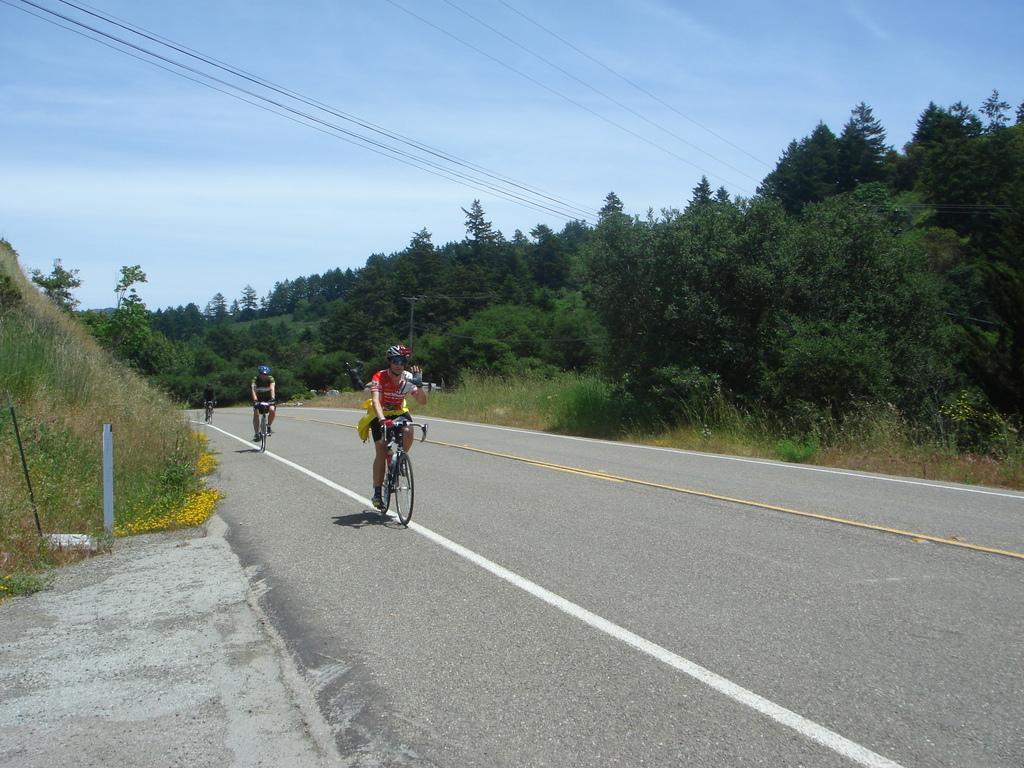Could you give a brief overview of what you see in this image? In this image, we can see people wearing helmets and are riding bicycles. In the background, there are trees, poles, wires and there is grass. At the top, there is sky and at the bottom, there is a road. 